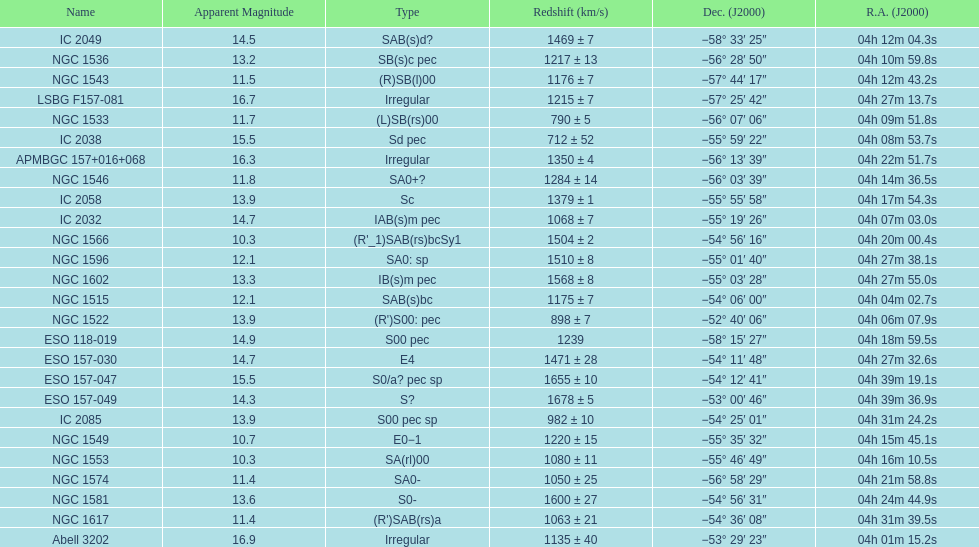Name the member with the highest apparent magnitude. Abell 3202. 